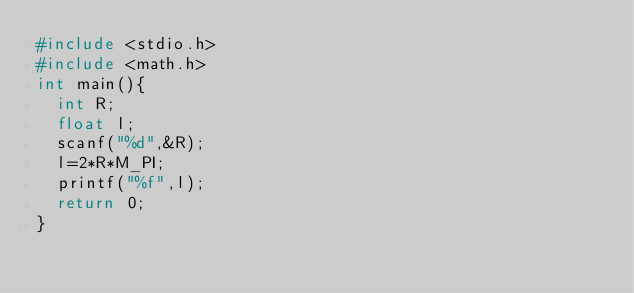Convert code to text. <code><loc_0><loc_0><loc_500><loc_500><_C_>#include <stdio.h>
#include <math.h>
int main(){
  int R;
  float l;
  scanf("%d",&R);
  l=2*R*M_PI;
  printf("%f",l);
  return 0;
}</code> 